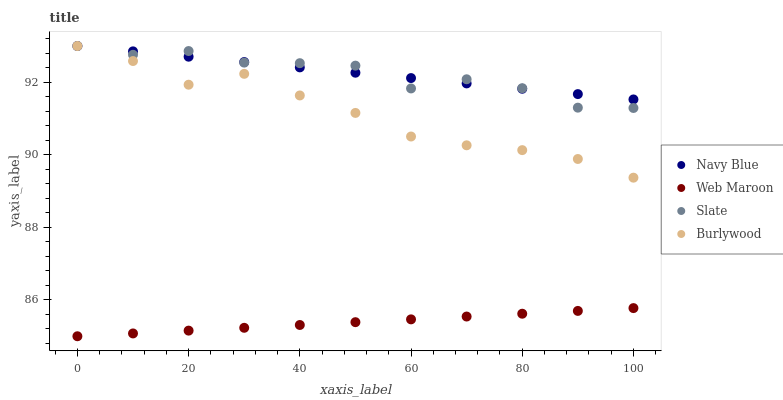Does Web Maroon have the minimum area under the curve?
Answer yes or no. Yes. Does Navy Blue have the maximum area under the curve?
Answer yes or no. Yes. Does Slate have the minimum area under the curve?
Answer yes or no. No. Does Slate have the maximum area under the curve?
Answer yes or no. No. Is Navy Blue the smoothest?
Answer yes or no. Yes. Is Slate the roughest?
Answer yes or no. Yes. Is Slate the smoothest?
Answer yes or no. No. Is Navy Blue the roughest?
Answer yes or no. No. Does Web Maroon have the lowest value?
Answer yes or no. Yes. Does Slate have the lowest value?
Answer yes or no. No. Does Slate have the highest value?
Answer yes or no. Yes. Does Web Maroon have the highest value?
Answer yes or no. No. Is Web Maroon less than Burlywood?
Answer yes or no. Yes. Is Slate greater than Web Maroon?
Answer yes or no. Yes. Does Burlywood intersect Navy Blue?
Answer yes or no. Yes. Is Burlywood less than Navy Blue?
Answer yes or no. No. Is Burlywood greater than Navy Blue?
Answer yes or no. No. Does Web Maroon intersect Burlywood?
Answer yes or no. No. 